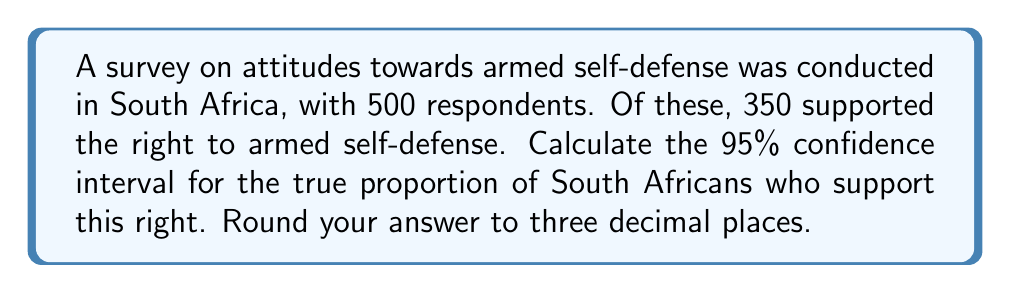Can you solve this math problem? Let's approach this step-by-step:

1) The sample proportion $\hat{p}$ is:
   $$\hat{p} = \frac{350}{500} = 0.7$$

2) The sample size $n$ is 500.

3) For a 95% confidence interval, we use $z_{\alpha/2} = 1.96$.

4) The standard error of the proportion is:
   $$SE = \sqrt{\frac{\hat{p}(1-\hat{p})}{n}} = \sqrt{\frac{0.7(1-0.7)}{500}} = 0.0205$$

5) The confidence interval formula is:
   $$\hat{p} \pm z_{\alpha/2} \cdot SE$$

6) Substituting our values:
   $$0.7 \pm 1.96 \cdot 0.0205$$

7) Calculating:
   $$0.7 \pm 0.04018$$

8) Therefore, the confidence interval is:
   $$(0.65982, 0.74018)$$

9) Rounding to three decimal places:
   $$(0.660, 0.740)$$
Answer: (0.660, 0.740) 